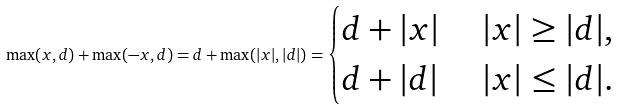<formula> <loc_0><loc_0><loc_500><loc_500>\max ( x , d ) + \max ( - x , d ) = d + \max ( | x | , | d | ) = \begin{cases} d + | x | & \ | x | \geq | d | , \\ d + | d | & \ | x | \leq | d | . \\ \end{cases}</formula> 